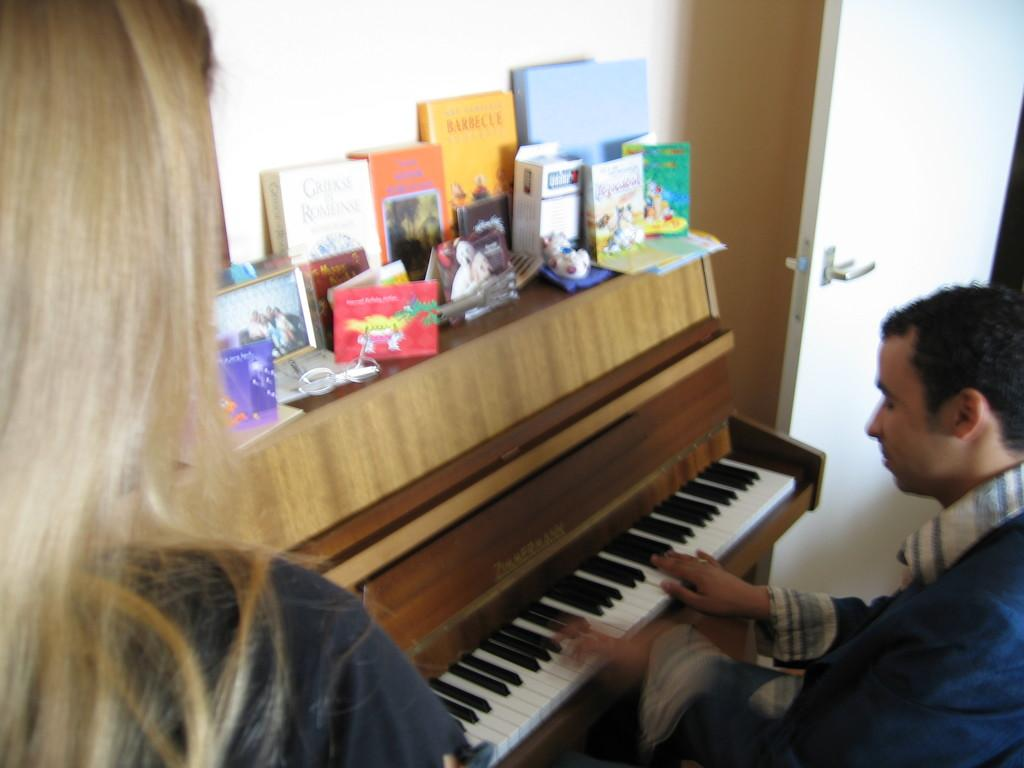What type of objects can be seen in the image? There are books, photo frames, and objects on a table in the image. What activity is the man in the image engaged in? The man is playing piano in the image. What feature is present on the door in the image? There is a door handle on the door in the image. What is the woman in the image doing? The woman is standing in the image. Reasoning: Let's think step by identifying the main subjects and objects in the image based on the provided facts. We then formulate questions that focus on the actions and characteristics of these subjects and objects, ensuring that each question can be answered definitively with the information given. We avoid yes/no questions and ensure that the language is simple and clear. Absurd Question/Answer: What type of wound can be seen on the toad in the image? There is no toad present in the image, so there is no wound to observe. What material is the lead used for in the image? There is no mention of lead in the image, so it is not possible to determine what material it might be used for. 